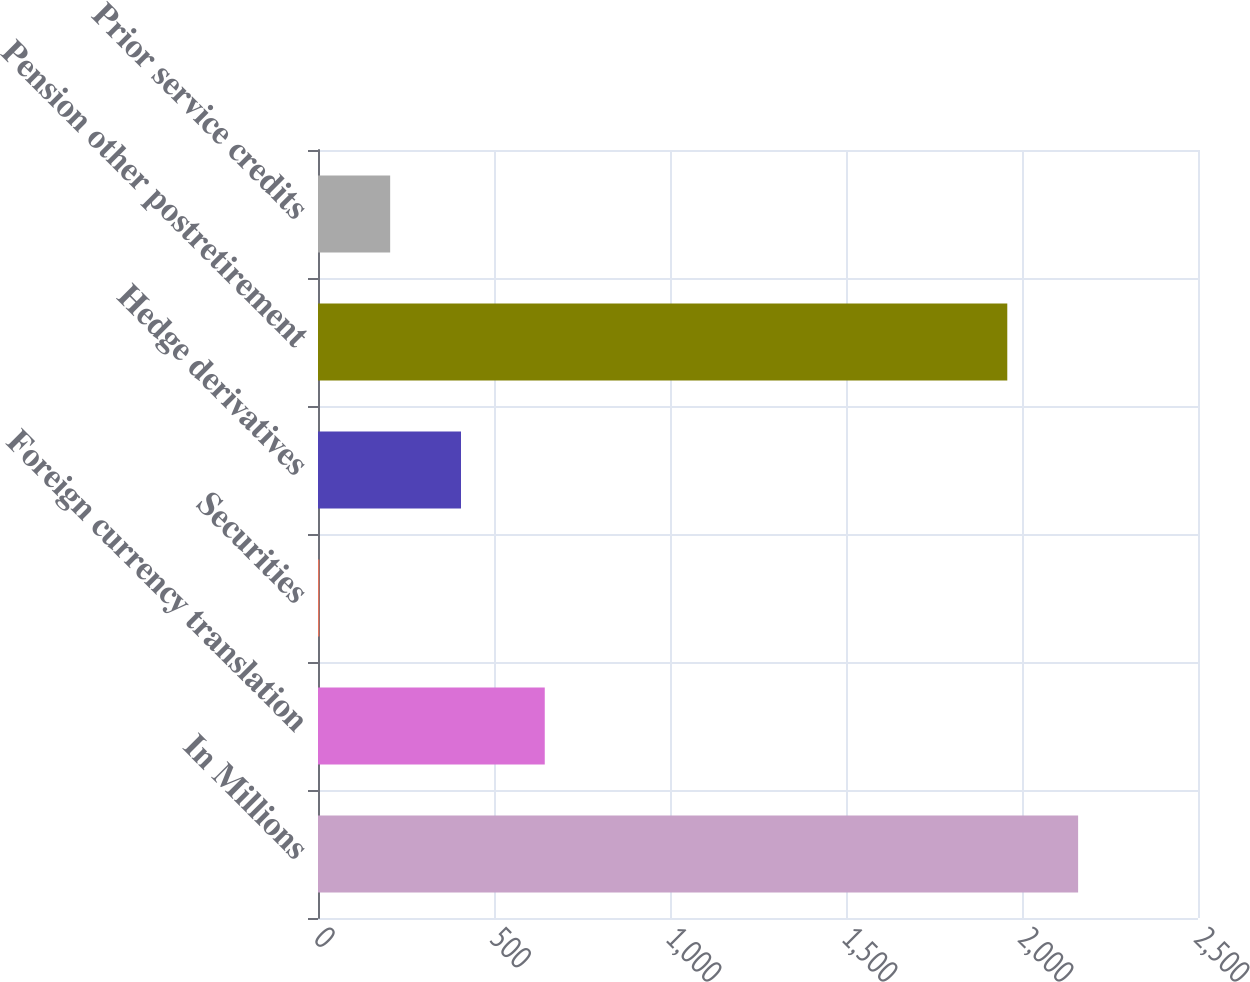Convert chart to OTSL. <chart><loc_0><loc_0><loc_500><loc_500><bar_chart><fcel>In Millions<fcel>Foreign currency translation<fcel>Securities<fcel>Hedge derivatives<fcel>Pension other postretirement<fcel>Prior service credits<nl><fcel>2159.42<fcel>644.2<fcel>3.8<fcel>406.24<fcel>1958.2<fcel>205.02<nl></chart> 